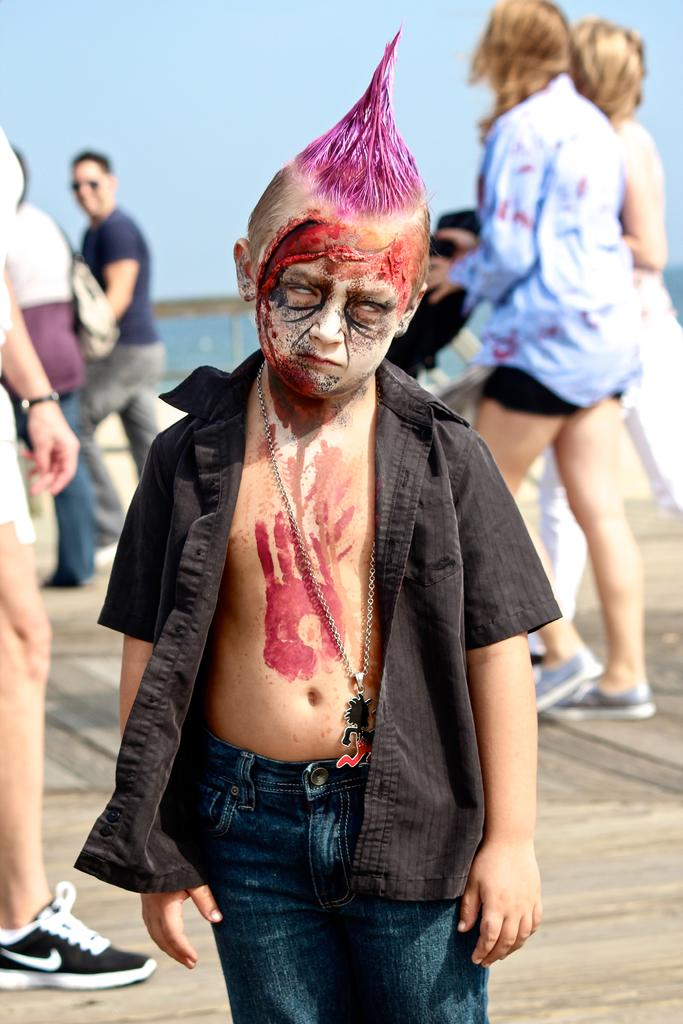Who is the main subject in the image? There is a boy in the image. What can be observed on the boy's face? The boy has face painting. Can you describe the image details be found about the people behind the boy? Yes, there is a group of people standing behind the boy. What is visible in the sky behind the people? The sky is visible behind the people. Where is the nest of the bird that is flying in the image? There is no bird or nest present in the image. What type of glove is the boy wearing in the image? The image does not show the boy wearing a glove. 